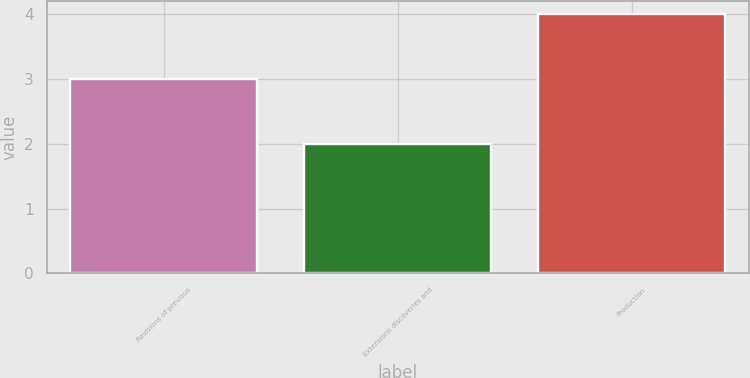Convert chart. <chart><loc_0><loc_0><loc_500><loc_500><bar_chart><fcel>Revisions of previous<fcel>Extensions discoveries and<fcel>Production<nl><fcel>3<fcel>2<fcel>4<nl></chart> 